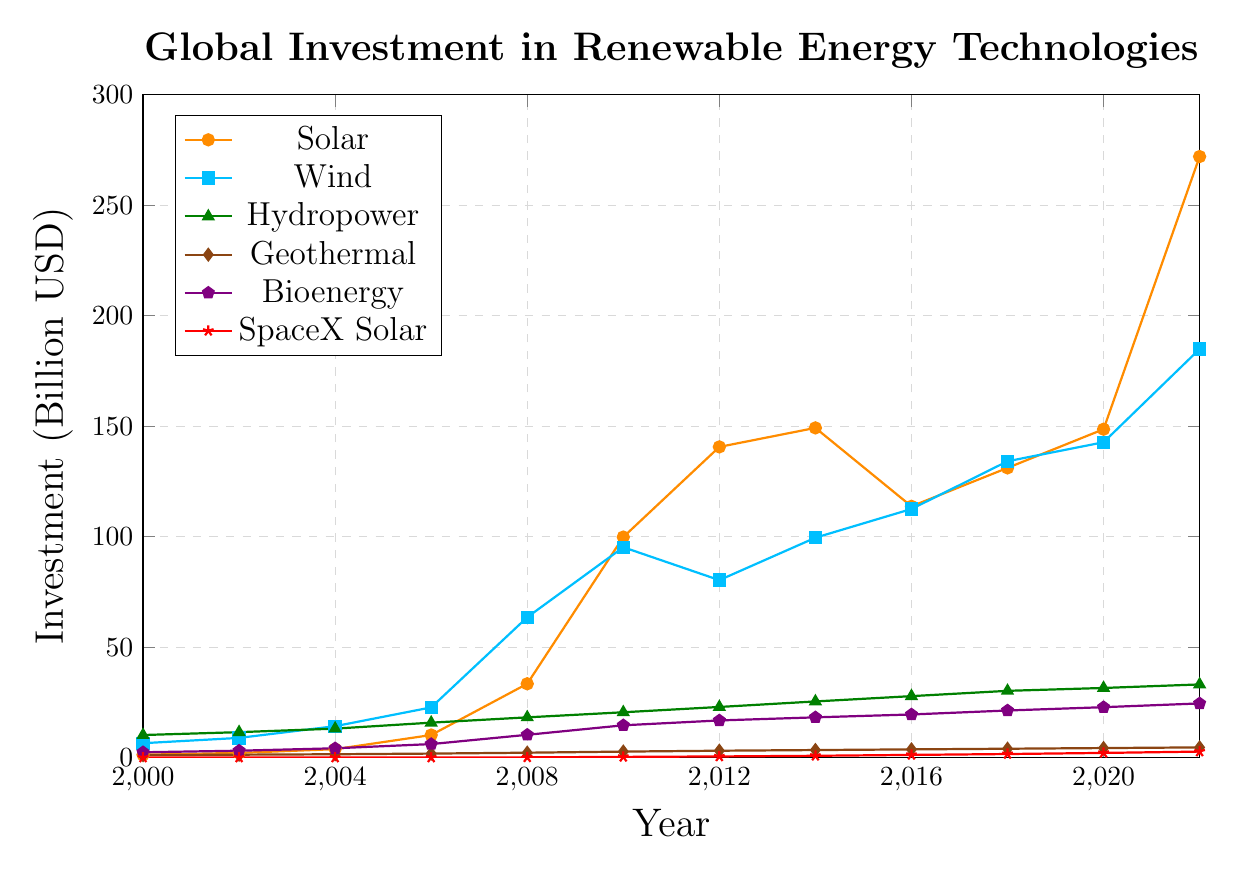What's the year with the highest investment in solar energy? By observing the highest point in the solar energy line (orange color), we can see that in 2022, the investment in solar energy reached its peak value.
Answer: 2022 Which renewable energy technology had the largest increase in investment from 2000 to 2022? To determine the largest increase, we need to subtract the 2000 investment value from the 2022 investment value for each technology and compare the results. Solar increased by 272.0 - 1.3 = 270.7 billion USD, Wind by 184.9 - 6.5 = 178.4 billion USD, Hydropower by 33.1 - 10.2 = 22.9 billion USD, Geothermal by 4.6 - 1.1 = 3.5 billion USD, Bioenergy by 24.5 - 2.4 = 22.1 billion USD, SpaceX Solar by 2.7 - 0.0 = 2.7 billion USD. Therefore, Solar had the largest increase.
Answer: Solar By how much did bioenergy investment increase between 2012 and 2022? In 2012, the investment in bioenergy was 16.8 billion USD, and in 2022, it was 24.5 billion USD. The increase is 24.5 - 16.8 = 7.7 billion USD.
Answer: 7.7 billion USD Which technology had the smallest investment in 2022? Observing the investment values in 2022, SpaceX Solar had the smallest investment at 2.7 billion USD compared to the other technologies.
Answer: SpaceX Solar How did investments in wind energy change between 2010 and 2012? In 2010, investment in wind energy was 95.2 billion USD, and in 2012, it was 80.3 billion USD. This represents a decrease of 95.2 - 80.3 = 14.9 billion USD.
Answer: Decreased by 14.9 billion USD Compare the investments in solar and wind energy in 2016. Which had the higher investment and by how much? In 2016, investment in solar energy was 113.7 billion USD, and investment in wind energy was 112.5 billion USD. Solar energy had a higher investment by 113.7 - 112.5 = 1.2 billion USD.
Answer: Solar by 1.2 billion USD Between which consecutive years did hydropower see the largest increase in investment? Checking the investment changes between consecutive years: 
- 2000-2002: 11.5 - 10.2 = 1.3
- 2002-2004: 13.1 - 11.5 = 1.6
- 2004-2006: 15.8 - 13.1 = 2.7
- 2006-2008: 18.2 - 15.8 = 2.4
- 2008-2010: 20.5 - 18.2 = 2.3
- 2010-2012: 22.9 - 20.5 = 2.4
- 2012-2014: 25.4 - 22.9 = 2.5
- 2014-2016: 27.8 - 25.4 = 2.4
- 2016-2018: 30.2 - 27.8 = 2.4
- 2018-2020: 31.5 - 30.2 = 1.3
- 2020-2022: 33.1 - 31.5 = 1.6
The largest increase was between 2004 and 2006 with a change of 2.7 billion USD.
Answer: 2004-2006 What was the total investment in renewable energy technologies (excluding SpaceX) in 2022? Summing up the investments for all technologies except SpaceX in 2022: 272.0 (Solar) + 184.9 (Wind) + 33.1 (Hydropower) + 4.6 (Geothermal) + 24.5 (Bioenergy) = 519.1 billion USD.
Answer: 519.1 billion USD By how much did SpaceX Solar investment increase from 2008 to 2020? In 2008, the investment was 0.1 billion USD, and in 2020, it was 2.1 billion USD. The increase is 2.1 - 0.1 = 2.0 billion USD.
Answer: 2.0 billion USD 